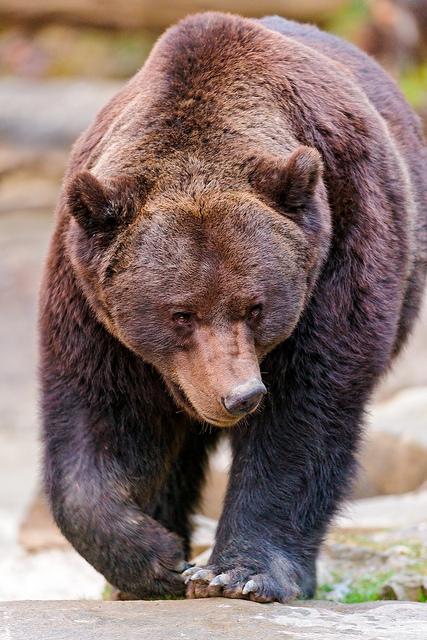Is this animal walking on all fours or upright?
Short answer required. All fours. What color is the bear?
Be succinct. Brown. What kind of bear is this?
Concise answer only. Grizzly. 